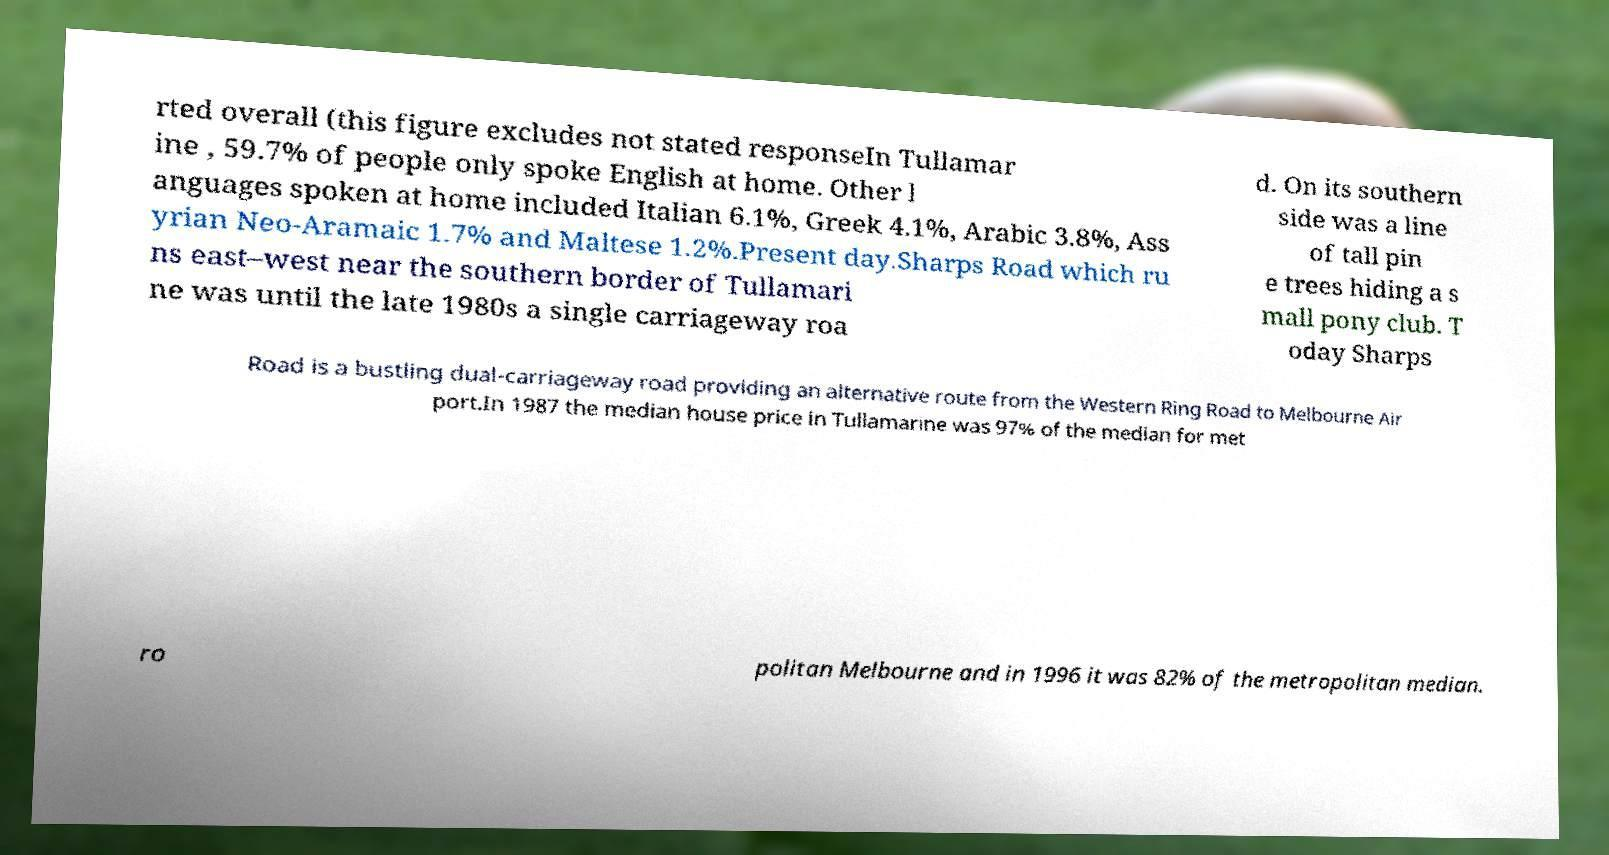Could you assist in decoding the text presented in this image and type it out clearly? rted overall (this figure excludes not stated responseIn Tullamar ine , 59.7% of people only spoke English at home. Other l anguages spoken at home included Italian 6.1%, Greek 4.1%, Arabic 3.8%, Ass yrian Neo-Aramaic 1.7% and Maltese 1.2%.Present day.Sharps Road which ru ns east–west near the southern border of Tullamari ne was until the late 1980s a single carriageway roa d. On its southern side was a line of tall pin e trees hiding a s mall pony club. T oday Sharps Road is a bustling dual-carriageway road providing an alternative route from the Western Ring Road to Melbourne Air port.In 1987 the median house price in Tullamarine was 97% of the median for met ro politan Melbourne and in 1996 it was 82% of the metropolitan median. 